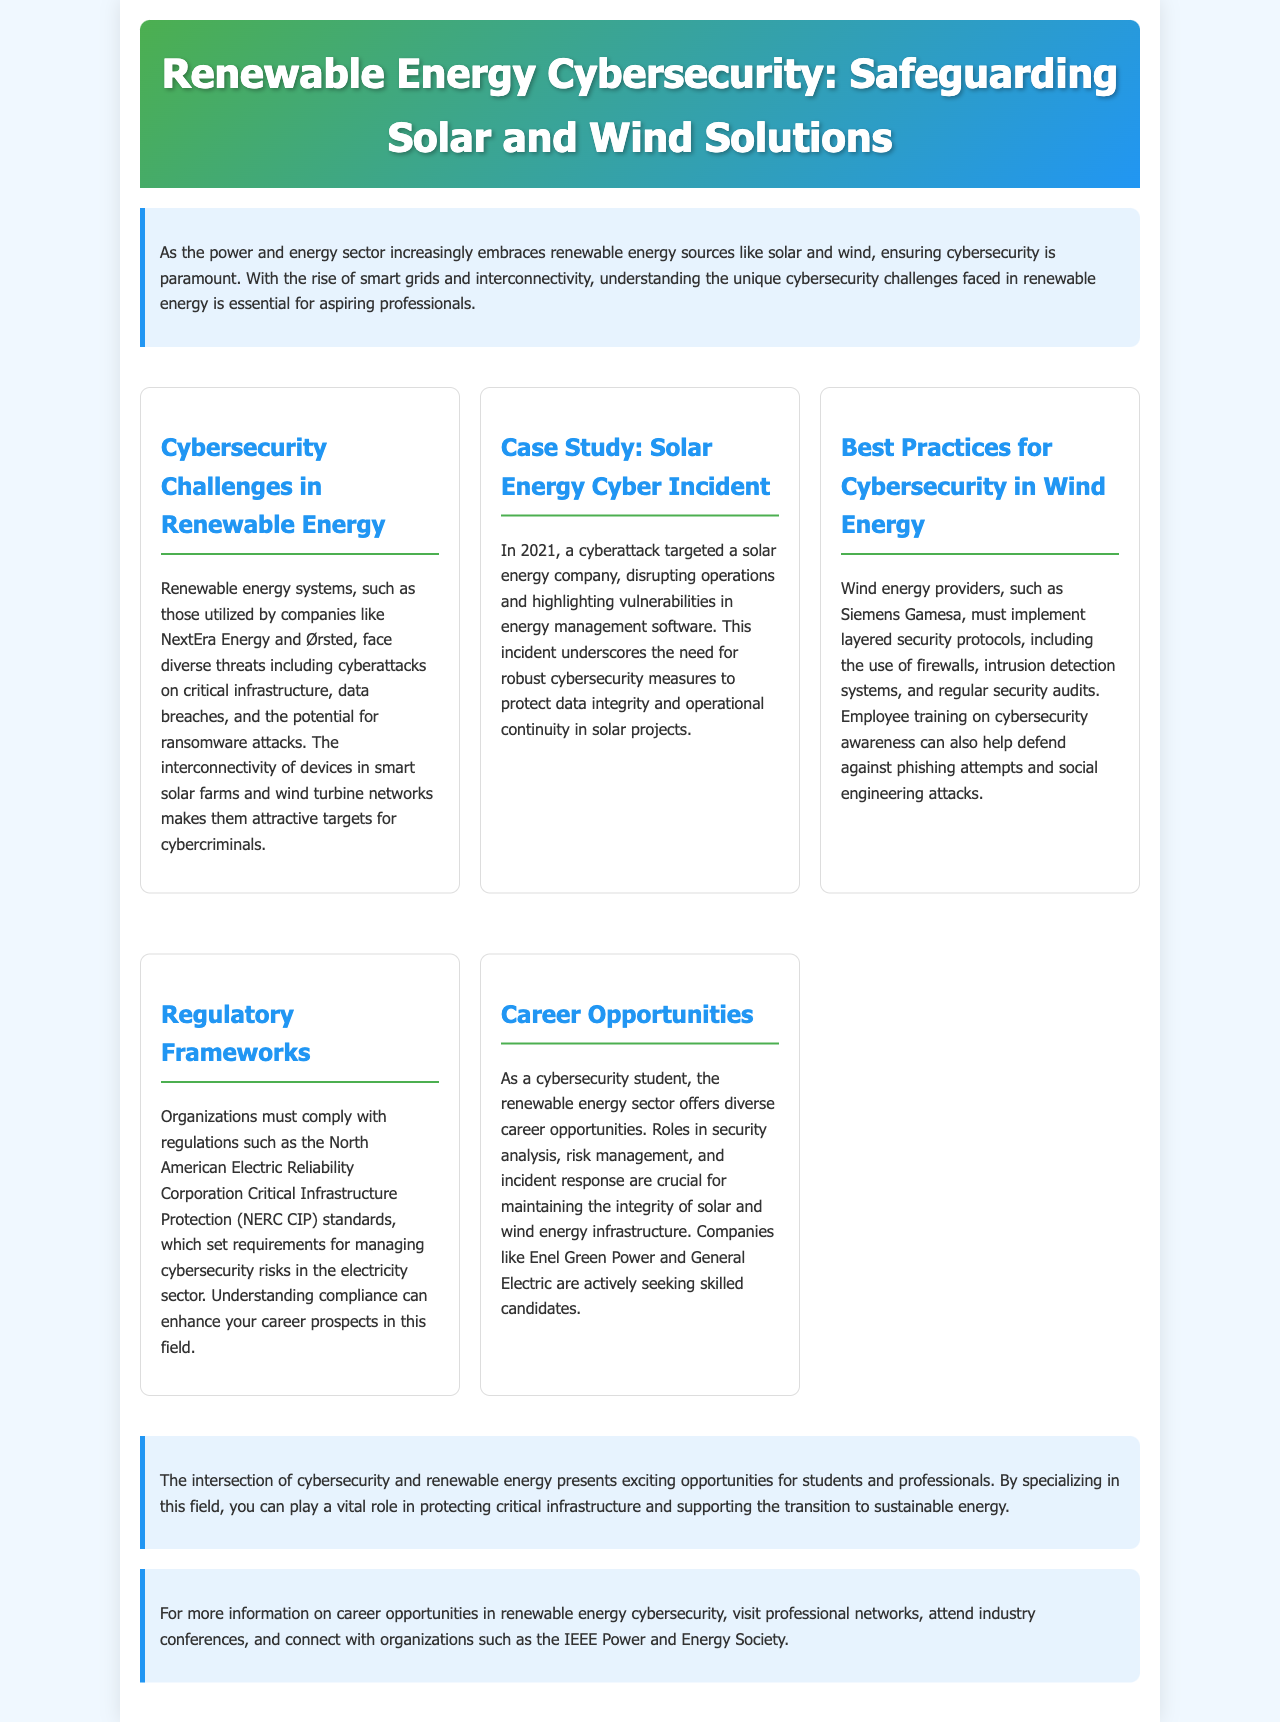What are the primary renewable energy sources mentioned? The primary renewable energy sources mentioned in the document are solar and wind.
Answer: solar and wind What cybersecurity challenges are referenced? The challenges mentioned include cyberattacks on critical infrastructure, data breaches, and ransomware attacks.
Answer: cyberattacks, data breaches, ransomware attacks What year did a solar energy cyber incident occur? The document specifies that a cyberattack targeted a solar energy company in 2021.
Answer: 2021 What regulatory framework is highlighted? The North American Electric Reliability Corporation Critical Infrastructure Protection standards are highlighted as important regulatory frameworks.
Answer: NERC CIP Which companies are mentioned as seeking skilled candidates? Companies like Enel Green Power and General Electric are noted as actively seeking skilled candidates in renewable energy cybersecurity.
Answer: Enel Green Power, General Electric What is one best practice for wind energy cybersecurity? One best practice mentioned is the implementation of firewalls.
Answer: firewalls Which organization is suggested for networking in the industry? The document suggests connecting with the IEEE Power and Energy Society for networking opportunities.
Answer: IEEE Power and Energy Society What roles are described in the career opportunities section? The document describes roles in security analysis, risk management, and incident response.
Answer: security analysis, risk management, incident response 